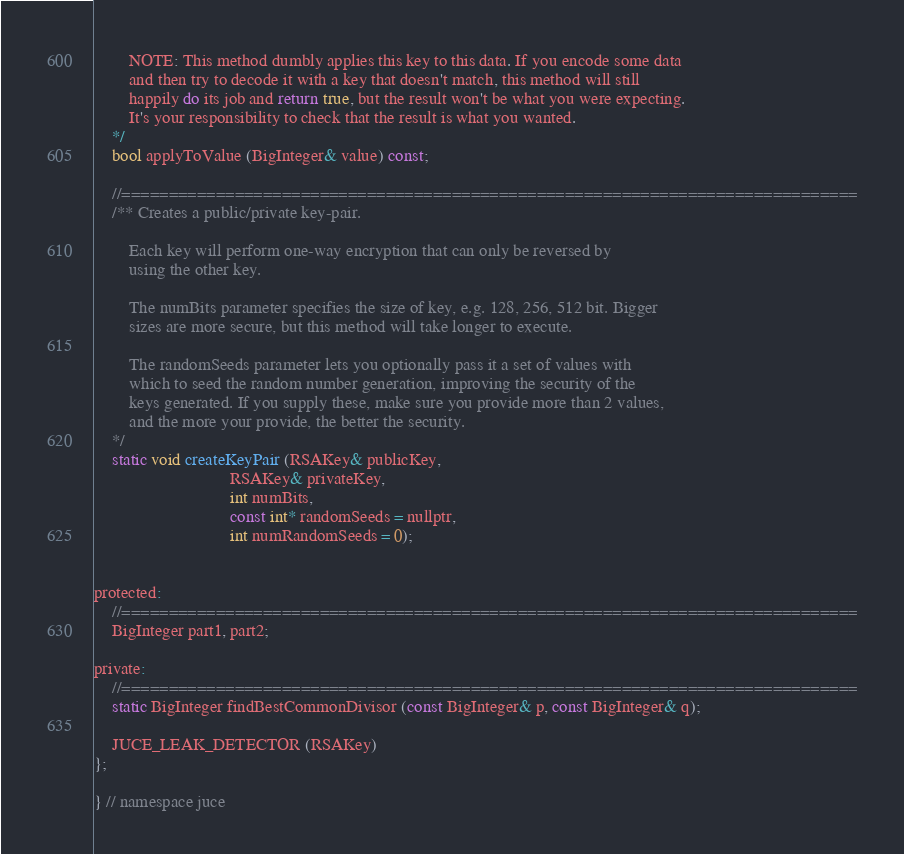<code> <loc_0><loc_0><loc_500><loc_500><_C_>        NOTE: This method dumbly applies this key to this data. If you encode some data
        and then try to decode it with a key that doesn't match, this method will still
        happily do its job and return true, but the result won't be what you were expecting.
        It's your responsibility to check that the result is what you wanted.
    */
    bool applyToValue (BigInteger& value) const;

    //==============================================================================
    /** Creates a public/private key-pair.

        Each key will perform one-way encryption that can only be reversed by
        using the other key.

        The numBits parameter specifies the size of key, e.g. 128, 256, 512 bit. Bigger
        sizes are more secure, but this method will take longer to execute.

        The randomSeeds parameter lets you optionally pass it a set of values with
        which to seed the random number generation, improving the security of the
        keys generated. If you supply these, make sure you provide more than 2 values,
        and the more your provide, the better the security.
    */
    static void createKeyPair (RSAKey& publicKey,
                               RSAKey& privateKey,
                               int numBits,
                               const int* randomSeeds = nullptr,
                               int numRandomSeeds = 0);


protected:
    //==============================================================================
    BigInteger part1, part2;

private:
    //==============================================================================
    static BigInteger findBestCommonDivisor (const BigInteger& p, const BigInteger& q);

    JUCE_LEAK_DETECTOR (RSAKey)
};

} // namespace juce
</code> 